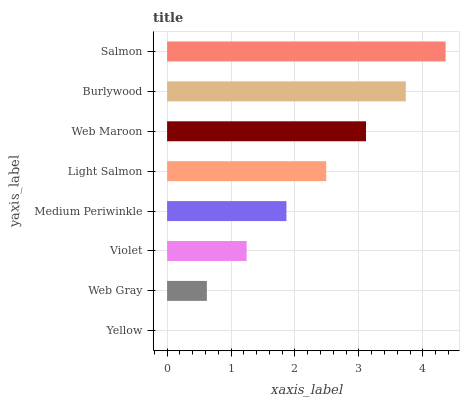Is Yellow the minimum?
Answer yes or no. Yes. Is Salmon the maximum?
Answer yes or no. Yes. Is Web Gray the minimum?
Answer yes or no. No. Is Web Gray the maximum?
Answer yes or no. No. Is Web Gray greater than Yellow?
Answer yes or no. Yes. Is Yellow less than Web Gray?
Answer yes or no. Yes. Is Yellow greater than Web Gray?
Answer yes or no. No. Is Web Gray less than Yellow?
Answer yes or no. No. Is Light Salmon the high median?
Answer yes or no. Yes. Is Medium Periwinkle the low median?
Answer yes or no. Yes. Is Salmon the high median?
Answer yes or no. No. Is Burlywood the low median?
Answer yes or no. No. 